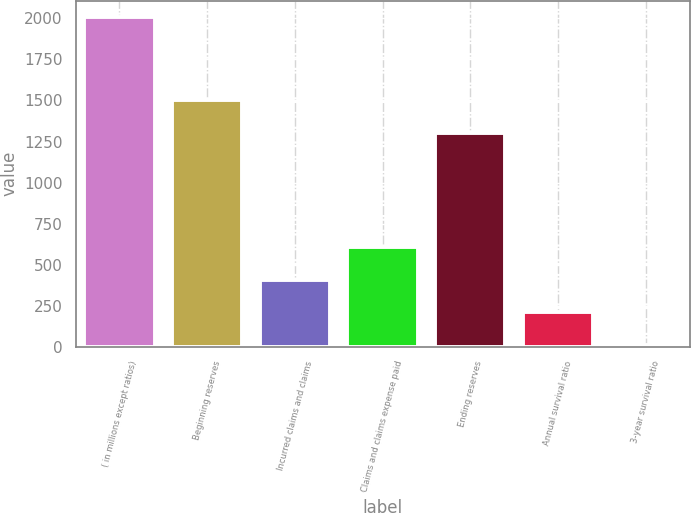Convert chart. <chart><loc_0><loc_0><loc_500><loc_500><bar_chart><fcel>( in millions except ratios)<fcel>Beginning reserves<fcel>Incurred claims and claims<fcel>Claims and claims expense paid<fcel>Ending reserves<fcel>Annual survival ratio<fcel>3-year survival ratio<nl><fcel>2007<fcel>1501.73<fcel>409.16<fcel>608.89<fcel>1302<fcel>209.43<fcel>9.7<nl></chart> 